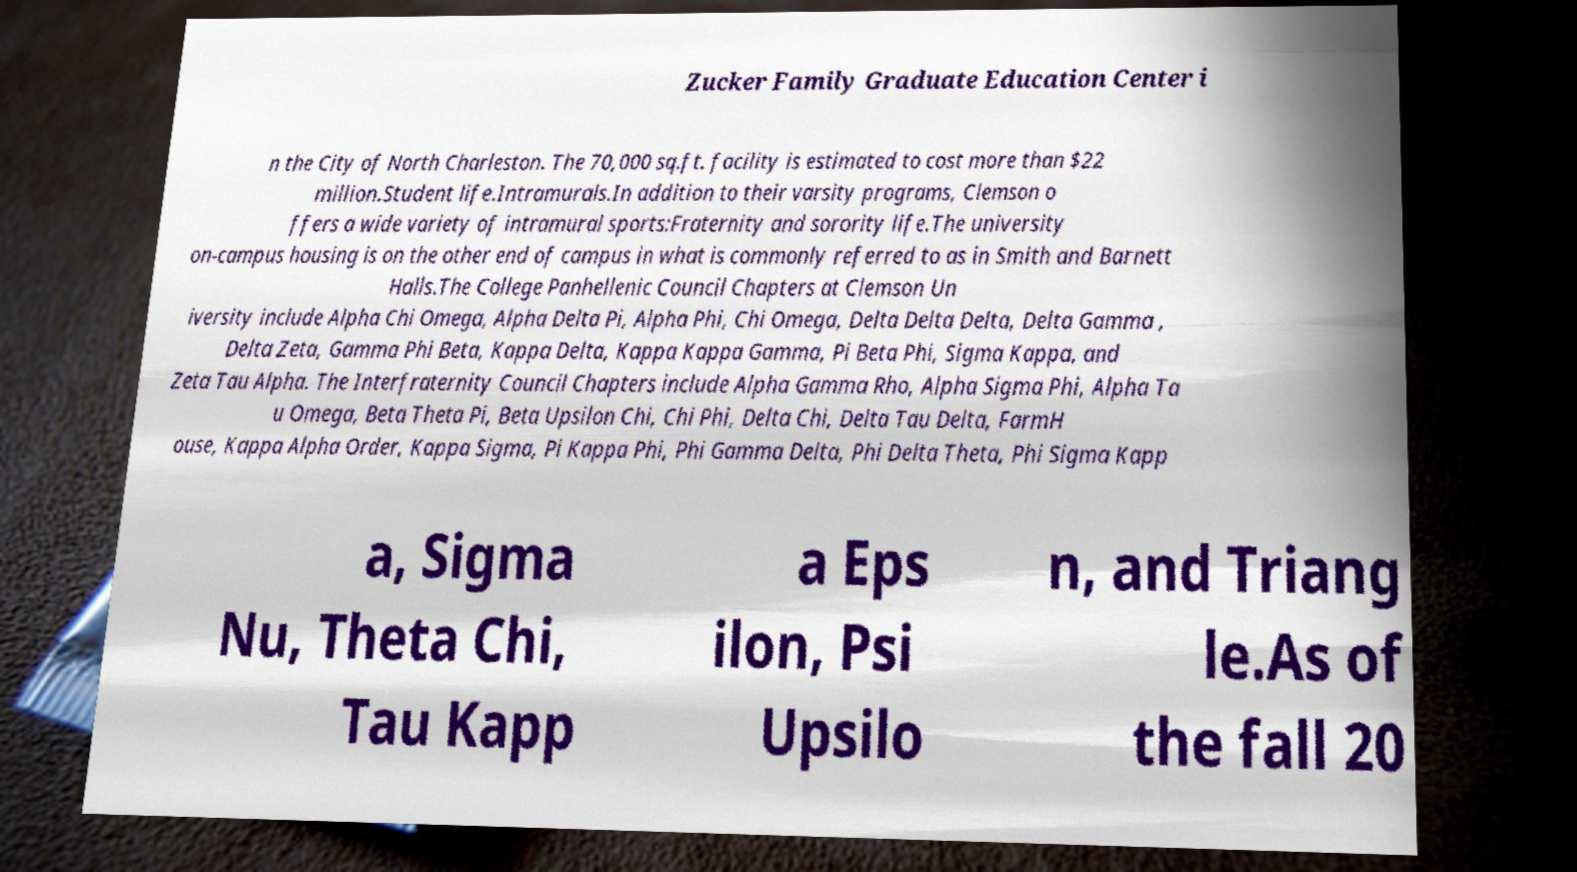Please identify and transcribe the text found in this image. Zucker Family Graduate Education Center i n the City of North Charleston. The 70,000 sq.ft. facility is estimated to cost more than $22 million.Student life.Intramurals.In addition to their varsity programs, Clemson o ffers a wide variety of intramural sports:Fraternity and sorority life.The university on-campus housing is on the other end of campus in what is commonly referred to as in Smith and Barnett Halls.The College Panhellenic Council Chapters at Clemson Un iversity include Alpha Chi Omega, Alpha Delta Pi, Alpha Phi, Chi Omega, Delta Delta Delta, Delta Gamma , Delta Zeta, Gamma Phi Beta, Kappa Delta, Kappa Kappa Gamma, Pi Beta Phi, Sigma Kappa, and Zeta Tau Alpha. The Interfraternity Council Chapters include Alpha Gamma Rho, Alpha Sigma Phi, Alpha Ta u Omega, Beta Theta Pi, Beta Upsilon Chi, Chi Phi, Delta Chi, Delta Tau Delta, FarmH ouse, Kappa Alpha Order, Kappa Sigma, Pi Kappa Phi, Phi Gamma Delta, Phi Delta Theta, Phi Sigma Kapp a, Sigma Nu, Theta Chi, Tau Kapp a Eps ilon, Psi Upsilo n, and Triang le.As of the fall 20 